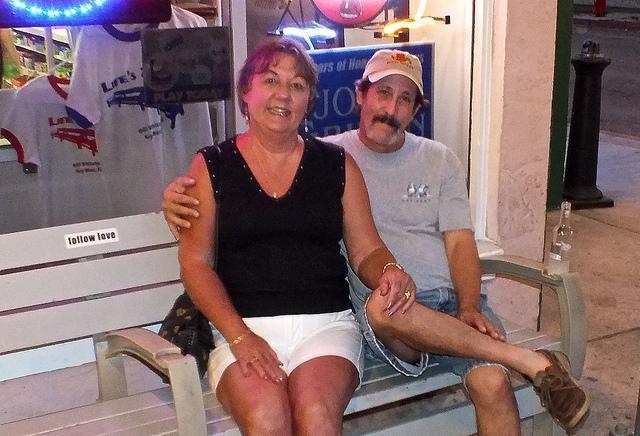How many people are sitting?
Give a very brief answer. 2. How many people are in the photo?
Give a very brief answer. 2. 